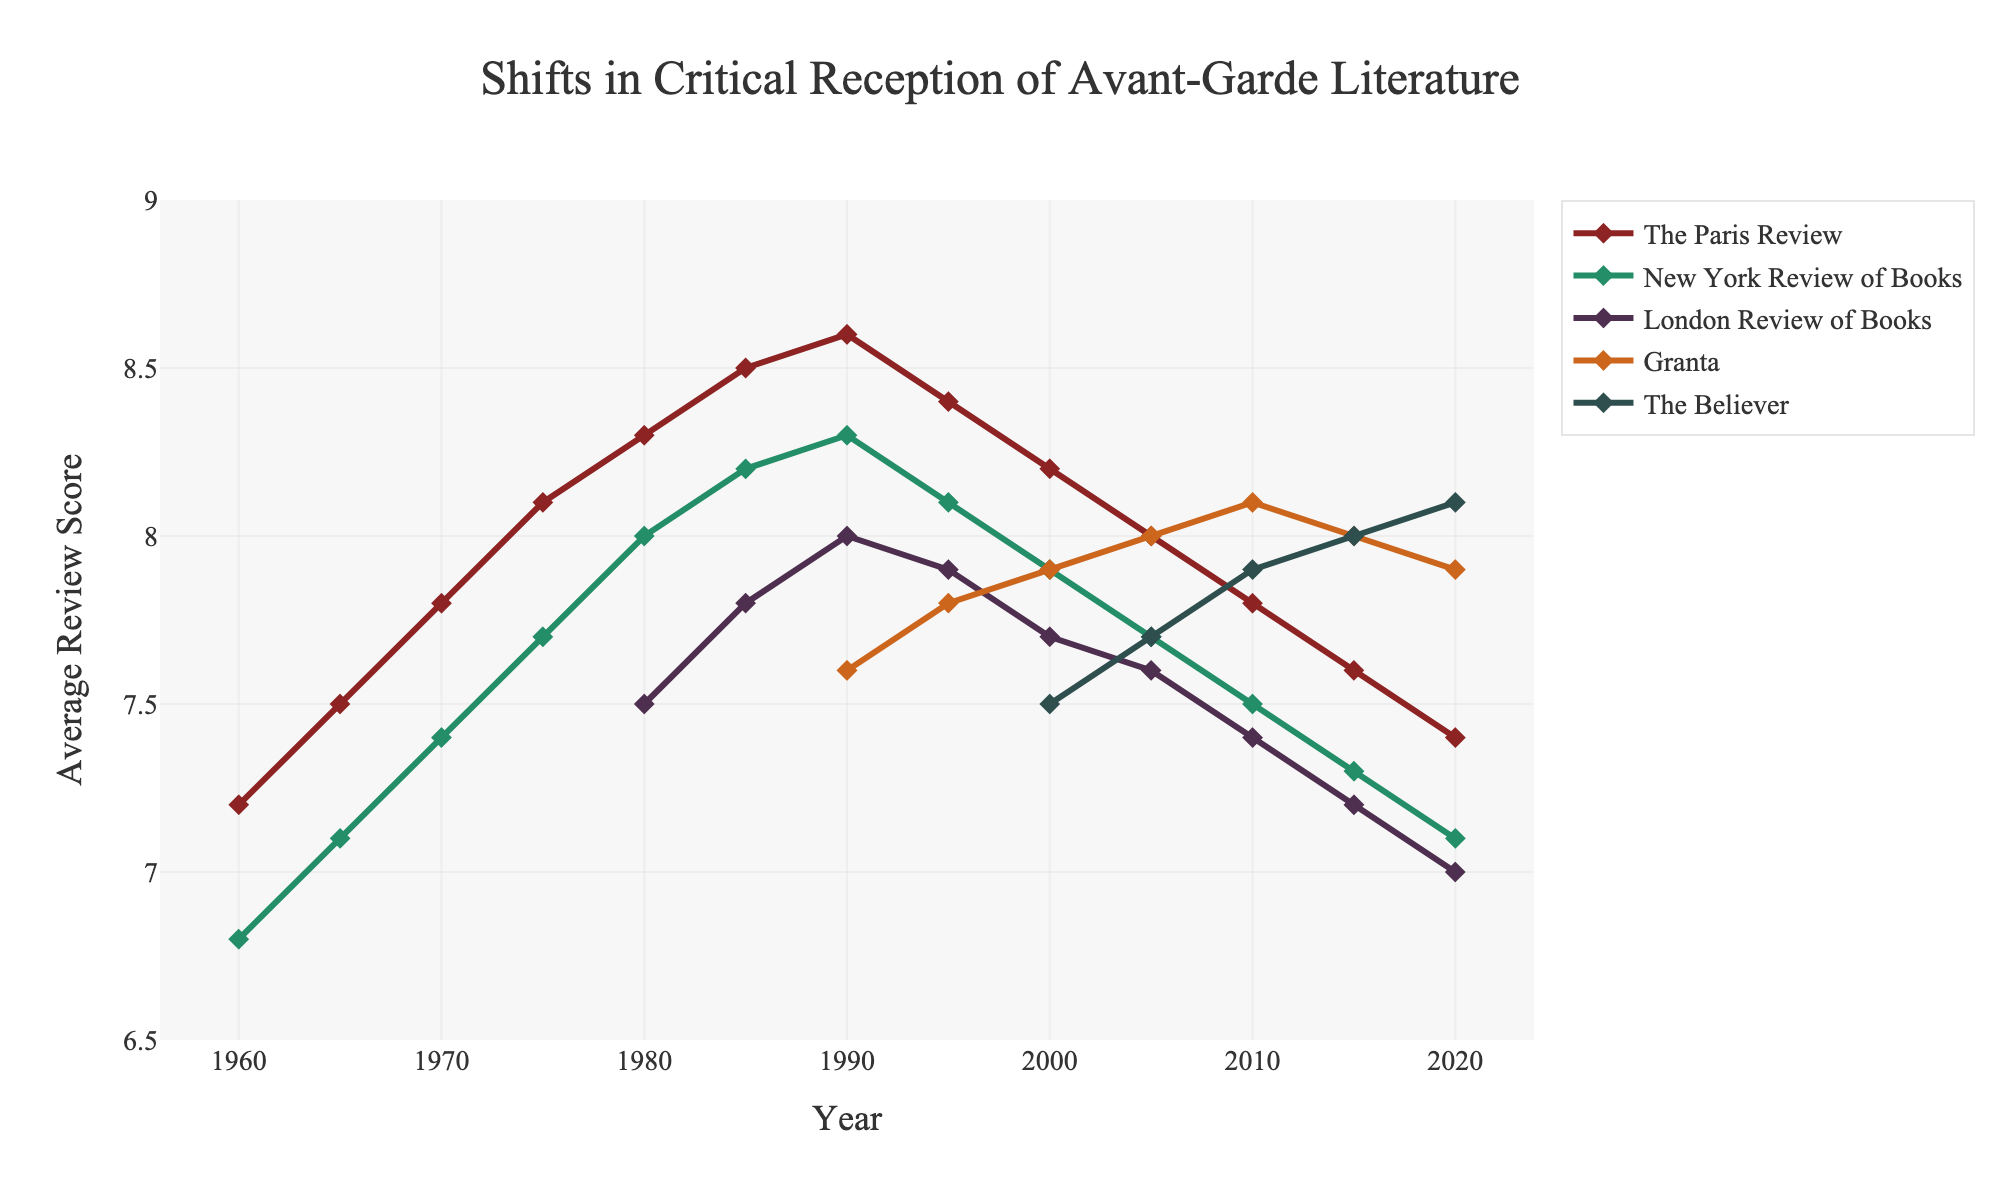what is the highest average review score for The Paris Review and in which year did it occur? Look at the line marked for The Paris Review and find the highest point on the y-axis. This occurs at 1990 with a score of 8.6
Answer: 1990, 8.6 compare the average review scores of The Believer and Granta in 2020. Which journal has the higher score? Look at the values for The Believer and Granta in the year 2020. The Believer has a score of 8.1, and Granta has a score of 7.9. Thus, The Believer has the higher score
Answer: The Believer how does the average review score of London Review of Books in 1980 compare to that in 2020? Find the values of the London Review of Books in 1980 and 2020, which are 7.5 and 7.0, respectively. Then compare them: 7.0 < 7.5
Answer: The score decreased what is the average review score of Granta over the years 1990 to 2020 inclusive? Sum the scores of Granta for the years 1990, 1995, 2000, 2005, 2010, 2015, and 2020: 7.6 + 7.8 + 7.9 + 8.0 + 8.1 + 8.0 + 7.9 = 55.3. There are 7 data points, so divide the sum by 7: 55.3 / 7 = 7.9
Answer: 7.9 in which year did the New York Review of Books have an average review score equal to the lowest score of The Believer? Identify the lowest score for The Believer, which is 7.5 in 2000. Then look for this score in the New York Review of Books, which happens in 2020
Answer: 2020 between 2000 and 2020, how many times did the average review score of The Paris Review drop by more than 0.2 points compared to the previous period? Look at the scores for The Paris Review in 2000 (8.2), 2005 (8.0), 2010 (7.8), 2015 (7.6), and 2020 (7.4). The drops greater than 0.2 are from 2000 to 2005 (0.2), 2005 to 2010 (0.2), 2010 to 2015 (0.2). Therefore, there are no drops greater than 0.2
Answer: 0 what is the range of average review scores for New York Review of Books from 1960 to 2020? Find the highest and lowest scores for New York Review of Books from 1960 (6.8) to 2020 (7.1). The range is the highest score (8.3 in 1990) minus the lowest score (6.8 in 1960): 8.3 - 6.8 = 1.5
Answer: 1.5 which journal shows a decreasing trend in average review scores from 1985 to 2020? Look at the trends for each journal from 1985 to 2020. The Paris Review shows a resting trend in this period as the scores drop from 1985 (8.5) to 2020 (7.4)
Answer: The Paris Review what was the average review score for the London Review of Books in 2005, and how does it compare to the score in 1980? Find the scores for London Review of Books in 2005 (7.6) and 1980 (7.5). Compare them, 7.6 is slightly higher than 7.5
Answer: 7.6, higher 